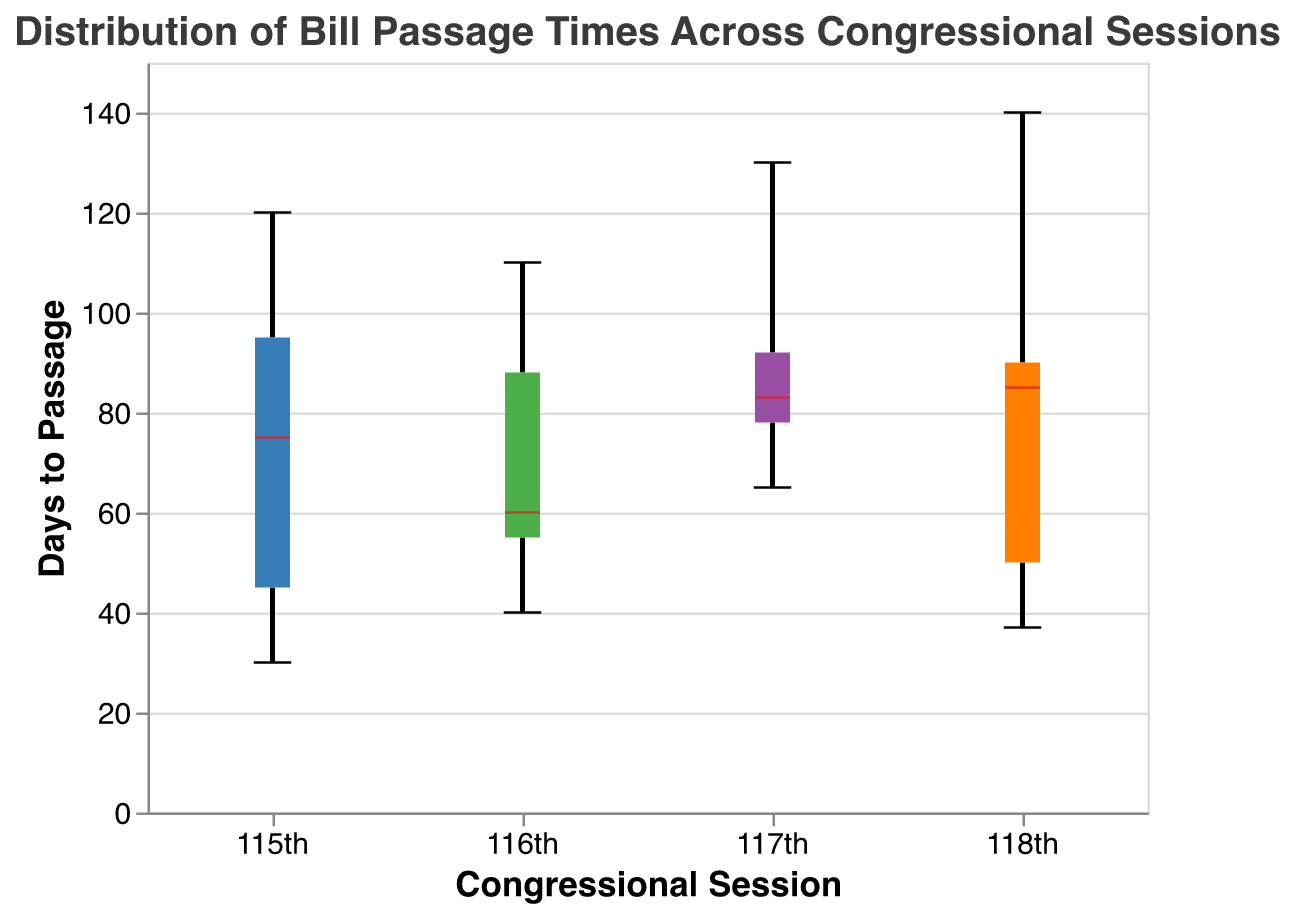What is the title of the figure? The title of the figure is displayed at the top.
Answer: Distribution of Bill Passage Times Across Congressional Sessions How many congressional sessions are represented in the plot? The x-axis of the plot shows the different congressional sessions represented by their labels.
Answer: 4 What is the median Days to Passage for the 117th congressional session? The red line within the box for the 117th session represents the median value of Days to Passage.
Answer: Approximately 83 Which congressional session has the widest range of Days to Passage? The range is represented by the distance between the minimum and maximum ticks for each session. The 118th session has the widest spread.
Answer: 118th What is the interquartile range (IQR) for the 116th session? The IQR is represented by the difference between the upper and lower quartiles (the top and bottom of the box) in a box plot.
Answer: (Approximately) 60 - 40 = 20 Which congressional session has the smallest amount of variation in Days to Passage? The variation is indicated by the height of the box; the smaller the box, the smaller the variation.
Answer: 116th Which congressional session has the highest median Days to Passage? The session with the highest median is indicated by the highest red line (median line) in the boxes.
Answer: 118th How do the median passage times of the 115th and 116th sessions compare? Compare the positions of the red median lines in the boxes for the 115th and 116th sessions.
Answer: The 115th session has a higher median than the 116th session Does the distribution of passage times for the 115th session indicate any outliers? Outliers are represented by points outside the whiskers of the box plot.
Answer: No, there are no noticeable outliers What can you infer about the skewness of the distribution for the 117th session? Skewness can be inferred by observing the lengths of the whiskers and the position of the median line within the box. For the 117th session, the longer upper whisker and the median slightly below the center suggest a right skew.
Answer: Slightly right-skewed 